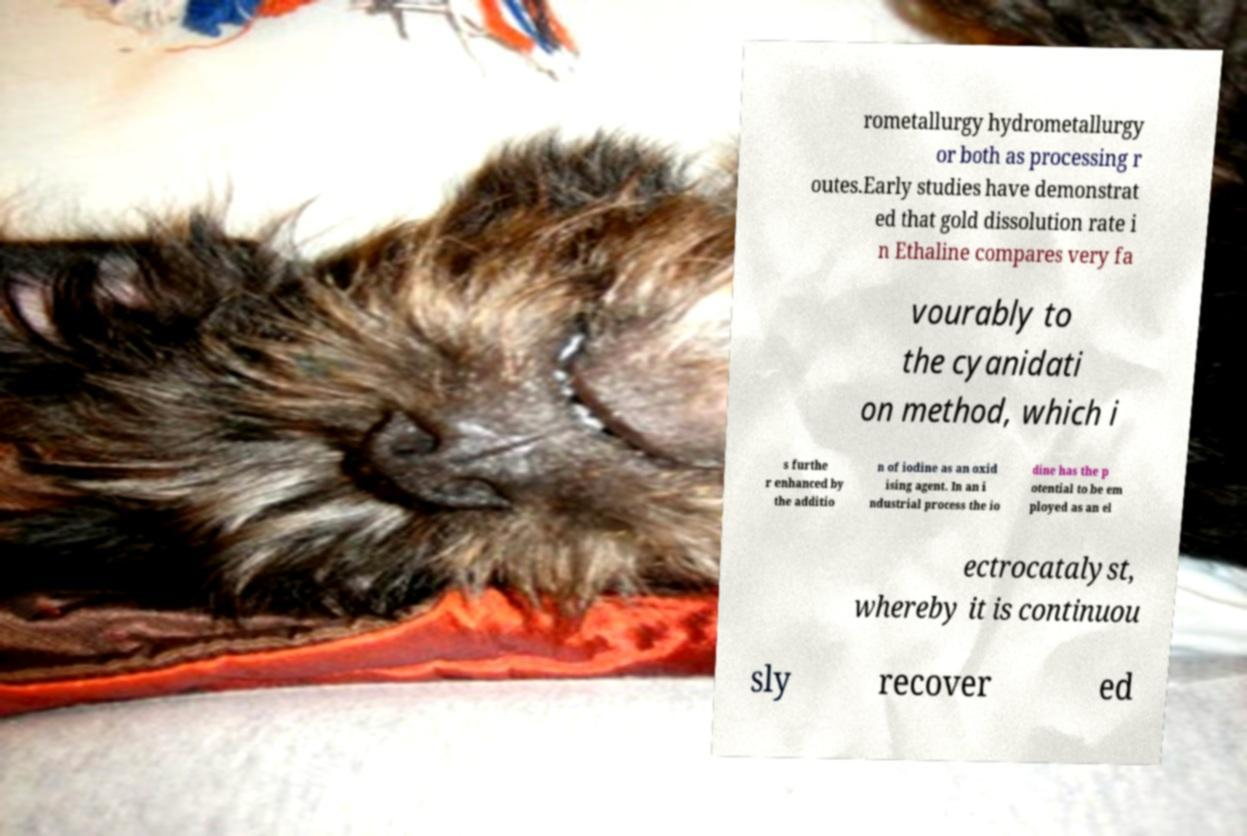What messages or text are displayed in this image? I need them in a readable, typed format. rometallurgy hydrometallurgy or both as processing r outes.Early studies have demonstrat ed that gold dissolution rate i n Ethaline compares very fa vourably to the cyanidati on method, which i s furthe r enhanced by the additio n of iodine as an oxid ising agent. In an i ndustrial process the io dine has the p otential to be em ployed as an el ectrocatalyst, whereby it is continuou sly recover ed 